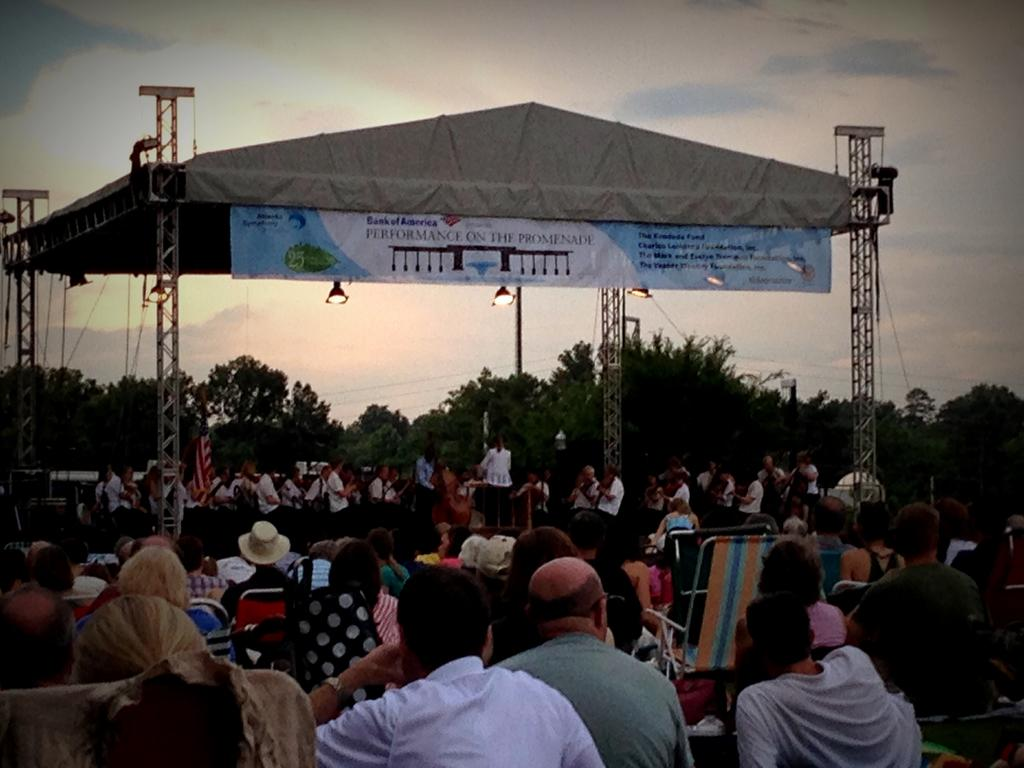What are the people in the image doing? There are people seated on chairs and standing on a dais in the image. What can be seen on the dais in the image? People are standing on a dais in the image. What is written on the banner in the image? There is a banner with text in the image. What type of lighting is visible in the image? There are lights visible in the image. What type of vegetation is present in the image? There are trees in the image. What is the condition of the sky in the image? The sky is cloudy in the image. What type of bells can be heard ringing in the image? There are no bells present in the image, and therefore no sound can be heard. How many giants are visible in the image? There are no giants present in the image. 